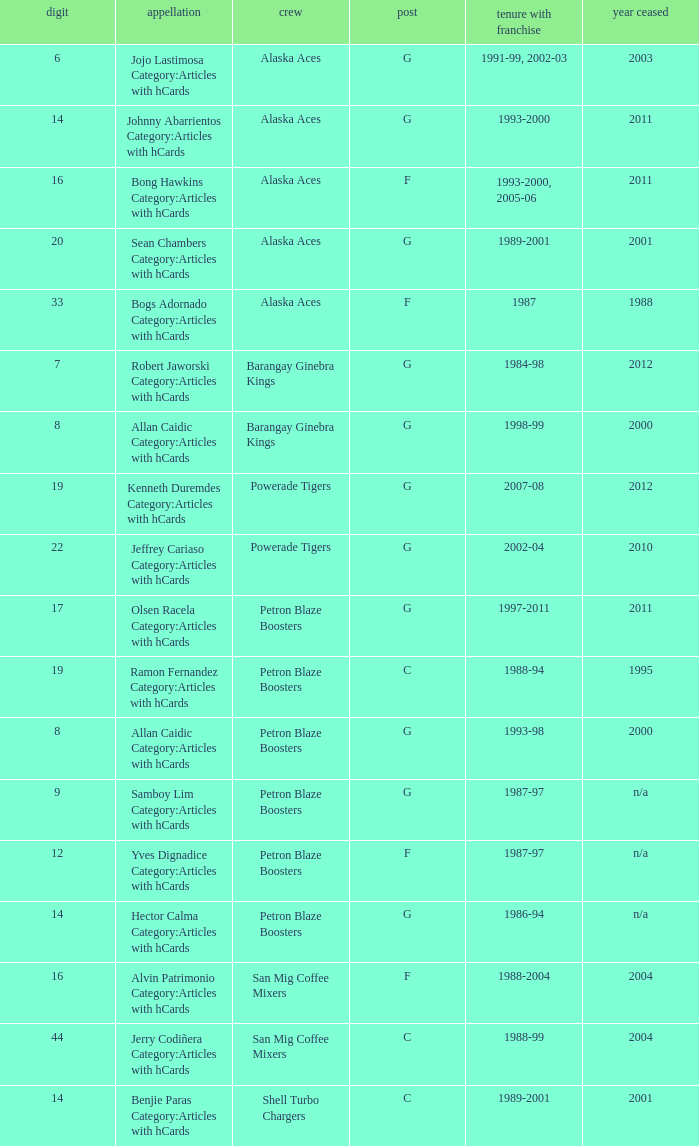Which team is number 14 and had a franchise in 1993-2000? Alaska Aces. Would you mind parsing the complete table? {'header': ['digit', 'appellation', 'crew', 'post', 'tenure with franchise', 'year ceased'], 'rows': [['6', 'Jojo Lastimosa Category:Articles with hCards', 'Alaska Aces', 'G', '1991-99, 2002-03', '2003'], ['14', 'Johnny Abarrientos Category:Articles with hCards', 'Alaska Aces', 'G', '1993-2000', '2011'], ['16', 'Bong Hawkins Category:Articles with hCards', 'Alaska Aces', 'F', '1993-2000, 2005-06', '2011'], ['20', 'Sean Chambers Category:Articles with hCards', 'Alaska Aces', 'G', '1989-2001', '2001'], ['33', 'Bogs Adornado Category:Articles with hCards', 'Alaska Aces', 'F', '1987', '1988'], ['7', 'Robert Jaworski Category:Articles with hCards', 'Barangay Ginebra Kings', 'G', '1984-98', '2012'], ['8', 'Allan Caidic Category:Articles with hCards', 'Barangay Ginebra Kings', 'G', '1998-99', '2000'], ['19', 'Kenneth Duremdes Category:Articles with hCards', 'Powerade Tigers', 'G', '2007-08', '2012'], ['22', 'Jeffrey Cariaso Category:Articles with hCards', 'Powerade Tigers', 'G', '2002-04', '2010'], ['17', 'Olsen Racela Category:Articles with hCards', 'Petron Blaze Boosters', 'G', '1997-2011', '2011'], ['19', 'Ramon Fernandez Category:Articles with hCards', 'Petron Blaze Boosters', 'C', '1988-94', '1995'], ['8', 'Allan Caidic Category:Articles with hCards', 'Petron Blaze Boosters', 'G', '1993-98', '2000'], ['9', 'Samboy Lim Category:Articles with hCards', 'Petron Blaze Boosters', 'G', '1987-97', 'n/a'], ['12', 'Yves Dignadice Category:Articles with hCards', 'Petron Blaze Boosters', 'F', '1987-97', 'n/a'], ['14', 'Hector Calma Category:Articles with hCards', 'Petron Blaze Boosters', 'G', '1986-94', 'n/a'], ['16', 'Alvin Patrimonio Category:Articles with hCards', 'San Mig Coffee Mixers', 'F', '1988-2004', '2004'], ['44', 'Jerry Codiñera Category:Articles with hCards', 'San Mig Coffee Mixers', 'C', '1988-99', '2004'], ['14', 'Benjie Paras Category:Articles with hCards', 'Shell Turbo Chargers', 'C', '1989-2001', '2001']]} 